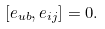<formula> <loc_0><loc_0><loc_500><loc_500>[ e _ { u b } , e _ { i j } ] = 0 .</formula> 